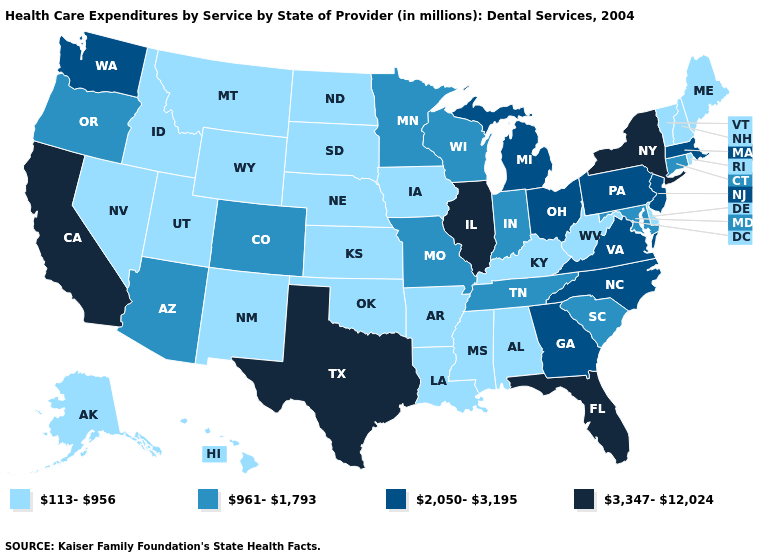Does New York have the highest value in the USA?
Quick response, please. Yes. Name the states that have a value in the range 961-1,793?
Concise answer only. Arizona, Colorado, Connecticut, Indiana, Maryland, Minnesota, Missouri, Oregon, South Carolina, Tennessee, Wisconsin. What is the highest value in the MidWest ?
Quick response, please. 3,347-12,024. What is the highest value in the USA?
Quick response, please. 3,347-12,024. Name the states that have a value in the range 2,050-3,195?
Be succinct. Georgia, Massachusetts, Michigan, New Jersey, North Carolina, Ohio, Pennsylvania, Virginia, Washington. Name the states that have a value in the range 2,050-3,195?
Answer briefly. Georgia, Massachusetts, Michigan, New Jersey, North Carolina, Ohio, Pennsylvania, Virginia, Washington. Does the map have missing data?
Answer briefly. No. Does the first symbol in the legend represent the smallest category?
Be succinct. Yes. What is the value of Illinois?
Give a very brief answer. 3,347-12,024. Among the states that border Missouri , does Oklahoma have the lowest value?
Concise answer only. Yes. How many symbols are there in the legend?
Keep it brief. 4. What is the highest value in the South ?
Write a very short answer. 3,347-12,024. What is the highest value in the USA?
Concise answer only. 3,347-12,024. Does Illinois have a higher value than Idaho?
Answer briefly. Yes. Does West Virginia have the same value as Missouri?
Answer briefly. No. 